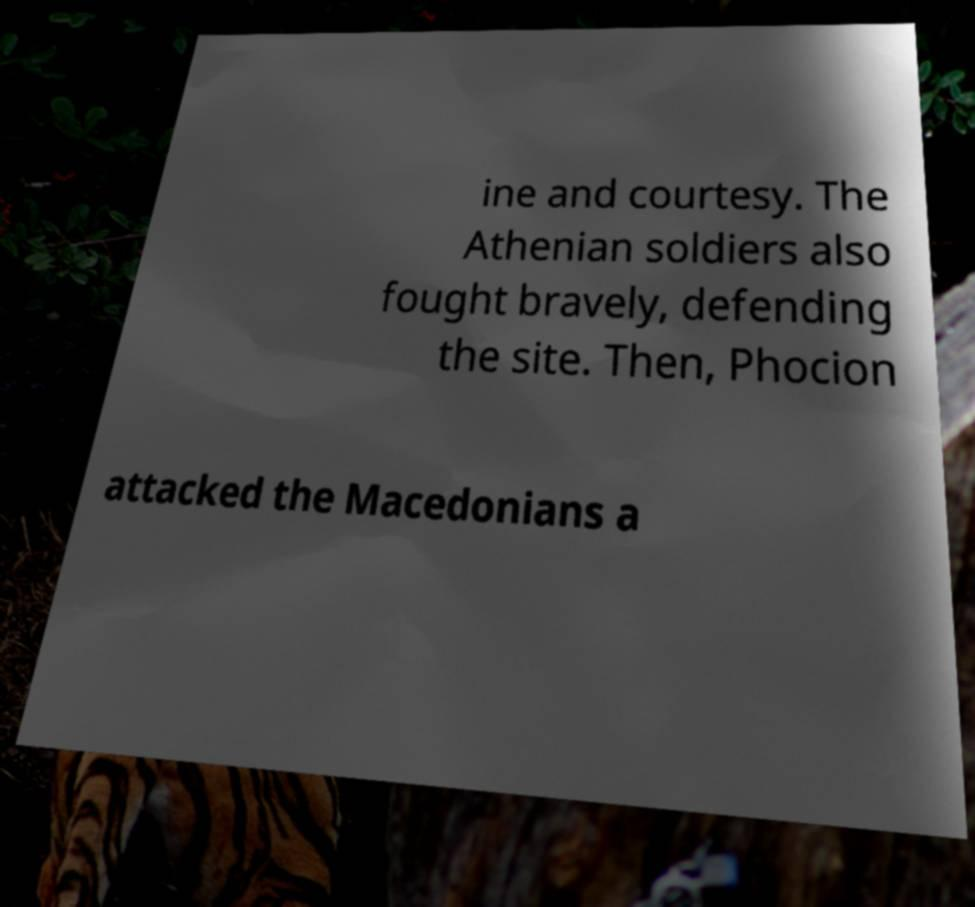There's text embedded in this image that I need extracted. Can you transcribe it verbatim? ine and courtesy. The Athenian soldiers also fought bravely, defending the site. Then, Phocion attacked the Macedonians a 